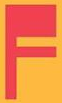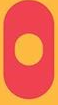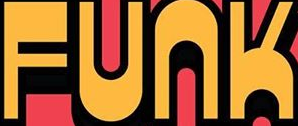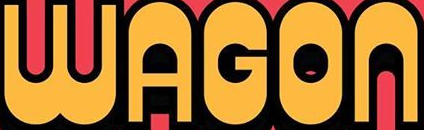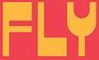Identify the words shown in these images in order, separated by a semicolon. F; O; FUNK; WAGON; FLY 